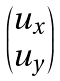<formula> <loc_0><loc_0><loc_500><loc_500>\begin{pmatrix} u _ { x } \\ u _ { y } \end{pmatrix}</formula> 